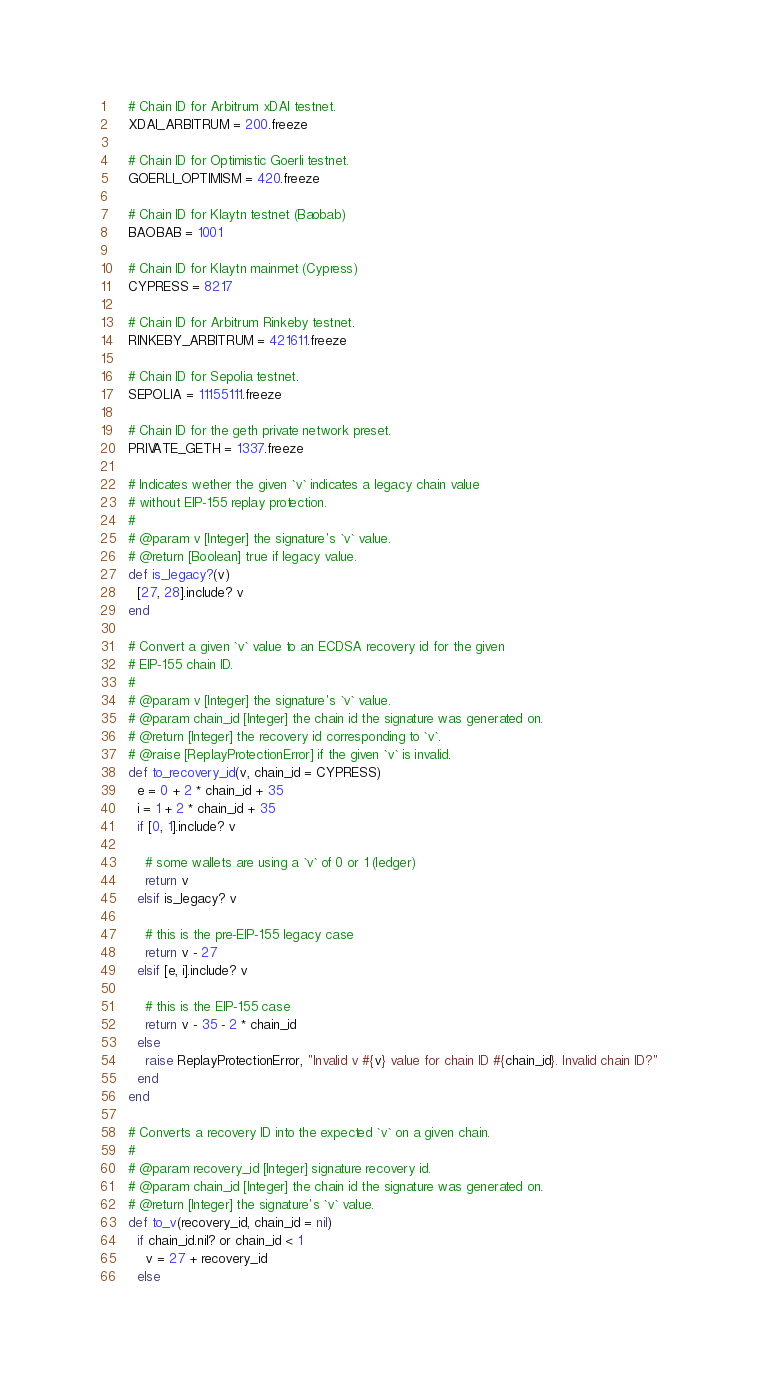<code> <loc_0><loc_0><loc_500><loc_500><_Ruby_>    # Chain ID for Arbitrum xDAI testnet.
    XDAI_ARBITRUM = 200.freeze

    # Chain ID for Optimistic Goerli testnet.
    GOERLI_OPTIMISM = 420.freeze

    # Chain ID for Klaytn testnet (Baobab)
    BAOBAB = 1001

    # Chain ID for Klaytn mainmet (Cypress)
    CYPRESS = 8217

    # Chain ID for Arbitrum Rinkeby testnet.
    RINKEBY_ARBITRUM = 421611.freeze

    # Chain ID for Sepolia testnet.
    SEPOLIA = 11155111.freeze

    # Chain ID for the geth private network preset.
    PRIVATE_GETH = 1337.freeze

    # Indicates wether the given `v` indicates a legacy chain value
    # without EIP-155 replay protection.
    #
    # @param v [Integer] the signature's `v` value.
    # @return [Boolean] true if legacy value.
    def is_legacy?(v)
      [27, 28].include? v
    end

    # Convert a given `v` value to an ECDSA recovery id for the given
    # EIP-155 chain ID.
    #
    # @param v [Integer] the signature's `v` value.
    # @param chain_id [Integer] the chain id the signature was generated on.
    # @return [Integer] the recovery id corresponding to `v`.
    # @raise [ReplayProtectionError] if the given `v` is invalid.
    def to_recovery_id(v, chain_id = CYPRESS)
      e = 0 + 2 * chain_id + 35
      i = 1 + 2 * chain_id + 35
      if [0, 1].include? v

        # some wallets are using a `v` of 0 or 1 (ledger)
        return v
      elsif is_legacy? v

        # this is the pre-EIP-155 legacy case
        return v - 27
      elsif [e, i].include? v

        # this is the EIP-155 case
        return v - 35 - 2 * chain_id
      else
        raise ReplayProtectionError, "Invalid v #{v} value for chain ID #{chain_id}. Invalid chain ID?"
      end
    end

    # Converts a recovery ID into the expected `v` on a given chain.
    #
    # @param recovery_id [Integer] signature recovery id.
    # @param chain_id [Integer] the chain id the signature was generated on.
    # @return [Integer] the signature's `v` value.
    def to_v(recovery_id, chain_id = nil)
      if chain_id.nil? or chain_id < 1
        v = 27 + recovery_id
      else</code> 